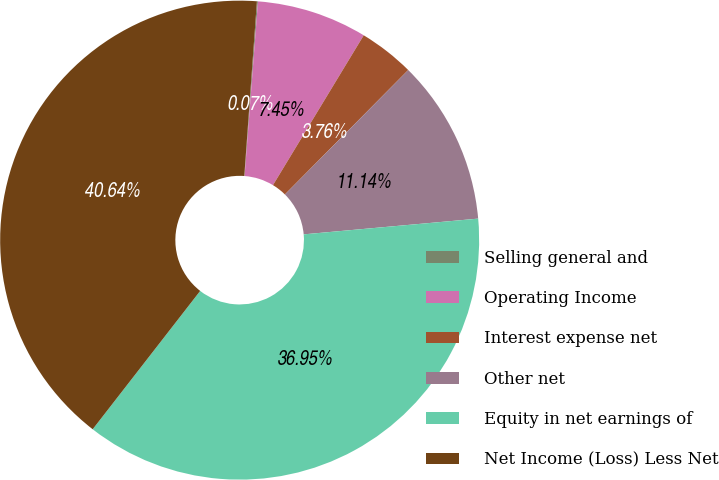Convert chart. <chart><loc_0><loc_0><loc_500><loc_500><pie_chart><fcel>Selling general and<fcel>Operating Income<fcel>Interest expense net<fcel>Other net<fcel>Equity in net earnings of<fcel>Net Income (Loss) Less Net<nl><fcel>0.07%<fcel>7.45%<fcel>3.76%<fcel>11.14%<fcel>36.95%<fcel>40.64%<nl></chart> 